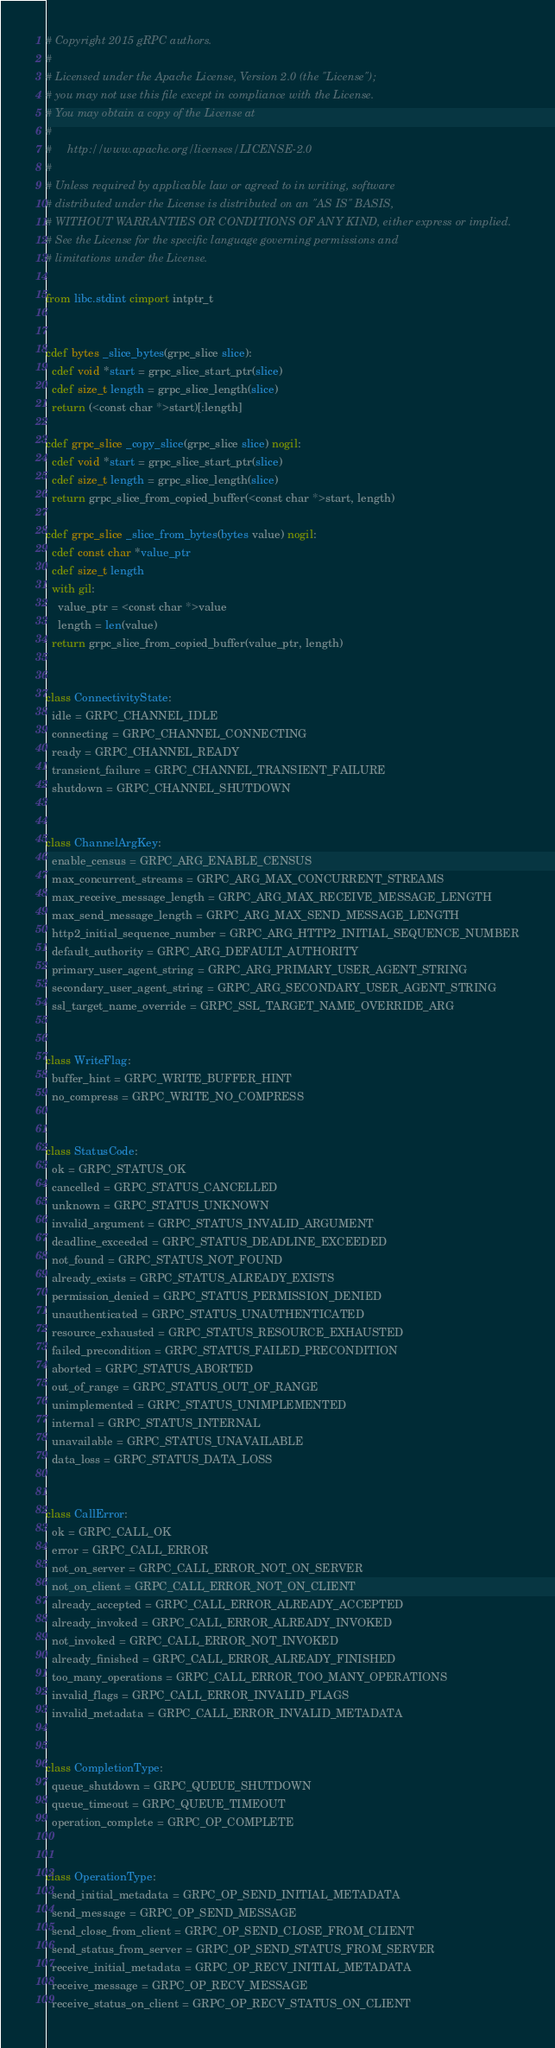<code> <loc_0><loc_0><loc_500><loc_500><_Cython_># Copyright 2015 gRPC authors.
#
# Licensed under the Apache License, Version 2.0 (the "License");
# you may not use this file except in compliance with the License.
# You may obtain a copy of the License at
#
#     http://www.apache.org/licenses/LICENSE-2.0
#
# Unless required by applicable law or agreed to in writing, software
# distributed under the License is distributed on an "AS IS" BASIS,
# WITHOUT WARRANTIES OR CONDITIONS OF ANY KIND, either express or implied.
# See the License for the specific language governing permissions and
# limitations under the License.

from libc.stdint cimport intptr_t


cdef bytes _slice_bytes(grpc_slice slice):
  cdef void *start = grpc_slice_start_ptr(slice)
  cdef size_t length = grpc_slice_length(slice)
  return (<const char *>start)[:length]

cdef grpc_slice _copy_slice(grpc_slice slice) nogil:
  cdef void *start = grpc_slice_start_ptr(slice)
  cdef size_t length = grpc_slice_length(slice)
  return grpc_slice_from_copied_buffer(<const char *>start, length)

cdef grpc_slice _slice_from_bytes(bytes value) nogil:
  cdef const char *value_ptr
  cdef size_t length
  with gil:
    value_ptr = <const char *>value
    length = len(value)
  return grpc_slice_from_copied_buffer(value_ptr, length)


class ConnectivityState:
  idle = GRPC_CHANNEL_IDLE
  connecting = GRPC_CHANNEL_CONNECTING
  ready = GRPC_CHANNEL_READY
  transient_failure = GRPC_CHANNEL_TRANSIENT_FAILURE
  shutdown = GRPC_CHANNEL_SHUTDOWN


class ChannelArgKey:
  enable_census = GRPC_ARG_ENABLE_CENSUS
  max_concurrent_streams = GRPC_ARG_MAX_CONCURRENT_STREAMS
  max_receive_message_length = GRPC_ARG_MAX_RECEIVE_MESSAGE_LENGTH
  max_send_message_length = GRPC_ARG_MAX_SEND_MESSAGE_LENGTH
  http2_initial_sequence_number = GRPC_ARG_HTTP2_INITIAL_SEQUENCE_NUMBER
  default_authority = GRPC_ARG_DEFAULT_AUTHORITY
  primary_user_agent_string = GRPC_ARG_PRIMARY_USER_AGENT_STRING
  secondary_user_agent_string = GRPC_ARG_SECONDARY_USER_AGENT_STRING
  ssl_target_name_override = GRPC_SSL_TARGET_NAME_OVERRIDE_ARG


class WriteFlag:
  buffer_hint = GRPC_WRITE_BUFFER_HINT
  no_compress = GRPC_WRITE_NO_COMPRESS


class StatusCode:
  ok = GRPC_STATUS_OK
  cancelled = GRPC_STATUS_CANCELLED
  unknown = GRPC_STATUS_UNKNOWN
  invalid_argument = GRPC_STATUS_INVALID_ARGUMENT
  deadline_exceeded = GRPC_STATUS_DEADLINE_EXCEEDED
  not_found = GRPC_STATUS_NOT_FOUND
  already_exists = GRPC_STATUS_ALREADY_EXISTS
  permission_denied = GRPC_STATUS_PERMISSION_DENIED
  unauthenticated = GRPC_STATUS_UNAUTHENTICATED
  resource_exhausted = GRPC_STATUS_RESOURCE_EXHAUSTED
  failed_precondition = GRPC_STATUS_FAILED_PRECONDITION
  aborted = GRPC_STATUS_ABORTED
  out_of_range = GRPC_STATUS_OUT_OF_RANGE
  unimplemented = GRPC_STATUS_UNIMPLEMENTED
  internal = GRPC_STATUS_INTERNAL
  unavailable = GRPC_STATUS_UNAVAILABLE
  data_loss = GRPC_STATUS_DATA_LOSS


class CallError:
  ok = GRPC_CALL_OK
  error = GRPC_CALL_ERROR
  not_on_server = GRPC_CALL_ERROR_NOT_ON_SERVER
  not_on_client = GRPC_CALL_ERROR_NOT_ON_CLIENT
  already_accepted = GRPC_CALL_ERROR_ALREADY_ACCEPTED
  already_invoked = GRPC_CALL_ERROR_ALREADY_INVOKED
  not_invoked = GRPC_CALL_ERROR_NOT_INVOKED
  already_finished = GRPC_CALL_ERROR_ALREADY_FINISHED
  too_many_operations = GRPC_CALL_ERROR_TOO_MANY_OPERATIONS
  invalid_flags = GRPC_CALL_ERROR_INVALID_FLAGS
  invalid_metadata = GRPC_CALL_ERROR_INVALID_METADATA


class CompletionType:
  queue_shutdown = GRPC_QUEUE_SHUTDOWN
  queue_timeout = GRPC_QUEUE_TIMEOUT
  operation_complete = GRPC_OP_COMPLETE


class OperationType:
  send_initial_metadata = GRPC_OP_SEND_INITIAL_METADATA
  send_message = GRPC_OP_SEND_MESSAGE
  send_close_from_client = GRPC_OP_SEND_CLOSE_FROM_CLIENT
  send_status_from_server = GRPC_OP_SEND_STATUS_FROM_SERVER
  receive_initial_metadata = GRPC_OP_RECV_INITIAL_METADATA
  receive_message = GRPC_OP_RECV_MESSAGE
  receive_status_on_client = GRPC_OP_RECV_STATUS_ON_CLIENT</code> 